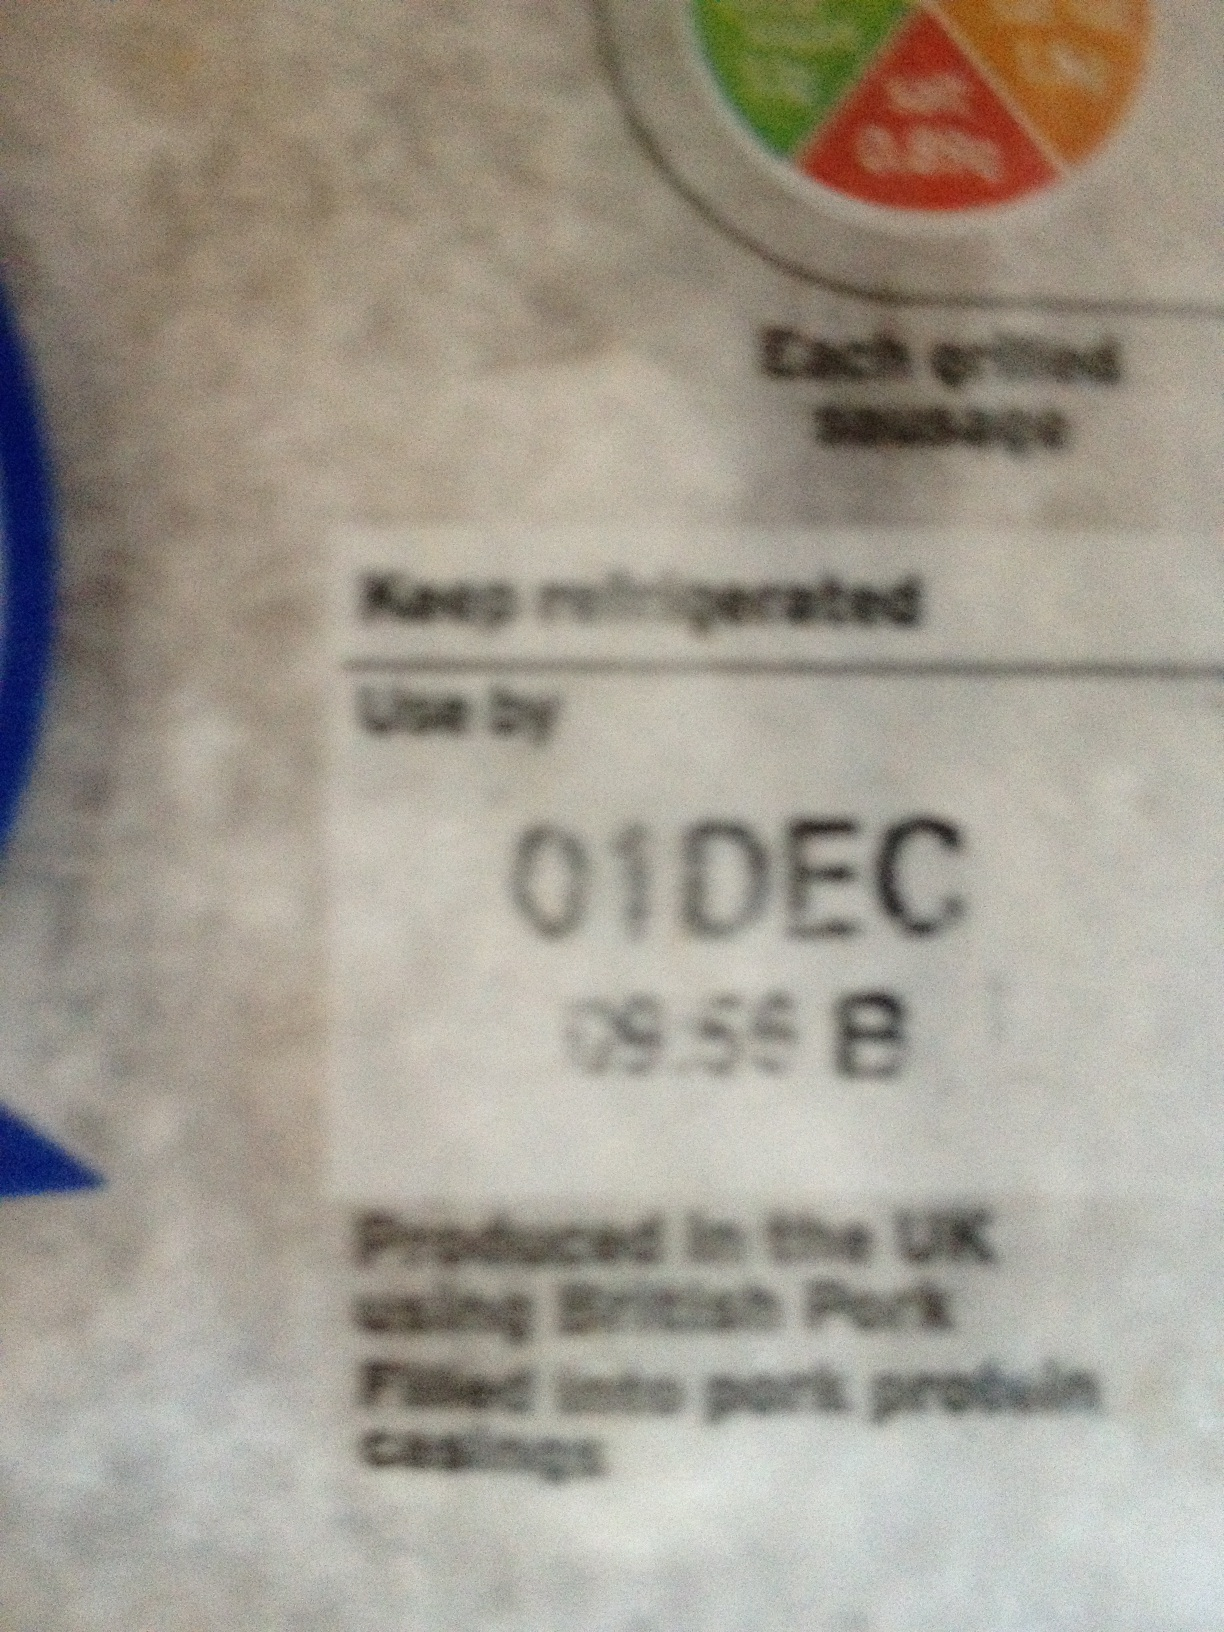Imagine if this label could speak. What story would it tell? I'm the guardian of your meal, crafted from the finest British Pork! I've journeyed through meticulous care and quality checks to ensure every bite you take is safe and delightful. Remember, my 'Use by' date is December 1st, so savor the freshness I pledge. Keep me cool in your fridge, for that's where I thrive, waiting to bring smiles to your table. If this product could be part of a unique recipe, what would it be? Imagine a rustic British farmhouse kitchen, where this fine pork transforms into a hearty, comforting casserole. Slow-cooked with root vegetables, herbs, and a splash of cider, it’s a feast that warms your soul. As you savor each bite on a chilly evening by the fireplace, the flavors sing of the countryside, of tradition and culinary love passed down through generations. 